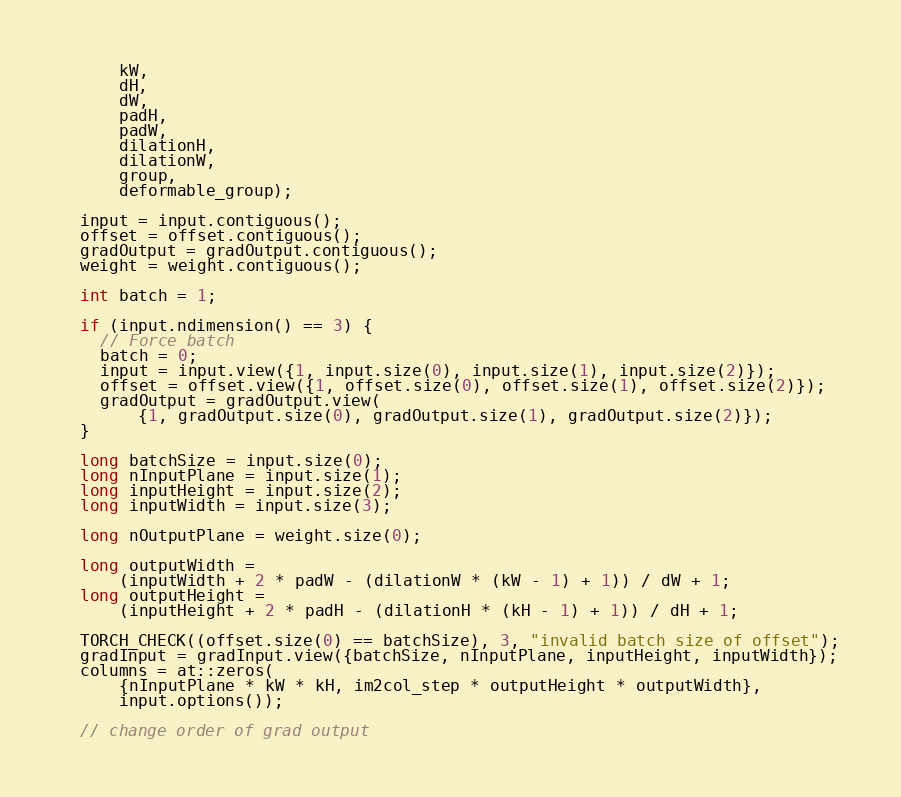<code> <loc_0><loc_0><loc_500><loc_500><_Cuda_>      kW,
      dH,
      dW,
      padH,
      padW,
      dilationH,
      dilationW,
      group,
      deformable_group);

  input = input.contiguous();
  offset = offset.contiguous();
  gradOutput = gradOutput.contiguous();
  weight = weight.contiguous();

  int batch = 1;

  if (input.ndimension() == 3) {
    // Force batch
    batch = 0;
    input = input.view({1, input.size(0), input.size(1), input.size(2)});
    offset = offset.view({1, offset.size(0), offset.size(1), offset.size(2)});
    gradOutput = gradOutput.view(
        {1, gradOutput.size(0), gradOutput.size(1), gradOutput.size(2)});
  }

  long batchSize = input.size(0);
  long nInputPlane = input.size(1);
  long inputHeight = input.size(2);
  long inputWidth = input.size(3);

  long nOutputPlane = weight.size(0);

  long outputWidth =
      (inputWidth + 2 * padW - (dilationW * (kW - 1) + 1)) / dW + 1;
  long outputHeight =
      (inputHeight + 2 * padH - (dilationH * (kH - 1) + 1)) / dH + 1;

  TORCH_CHECK((offset.size(0) == batchSize), 3, "invalid batch size of offset");
  gradInput = gradInput.view({batchSize, nInputPlane, inputHeight, inputWidth});
  columns = at::zeros(
      {nInputPlane * kW * kH, im2col_step * outputHeight * outputWidth},
      input.options());

  // change order of grad output</code> 